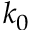<formula> <loc_0><loc_0><loc_500><loc_500>k _ { 0 }</formula> 